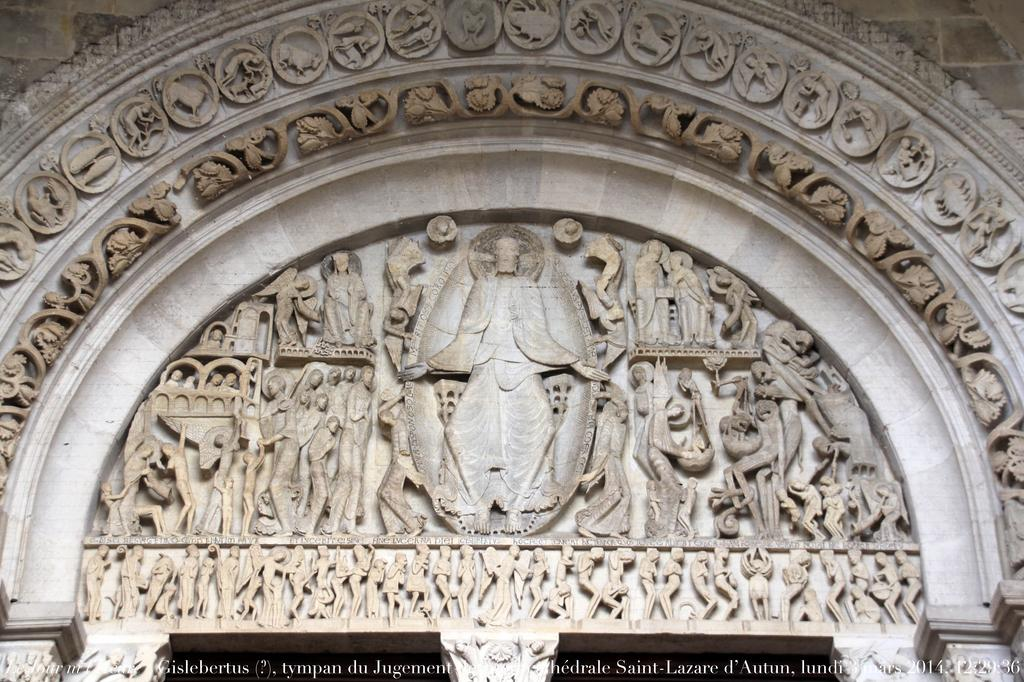What type of objects are featured in the image? There are sculptures in the image. Can you describe any additional elements in the image? Yes, there is some text at the bottom of the image. What type of shoes can be seen on the sculptures in the image? There are no shoes visible on the sculptures in the image. Can you describe the cave where the sculptures are located in the image? There is no cave present in the image; it features sculptures and text. 